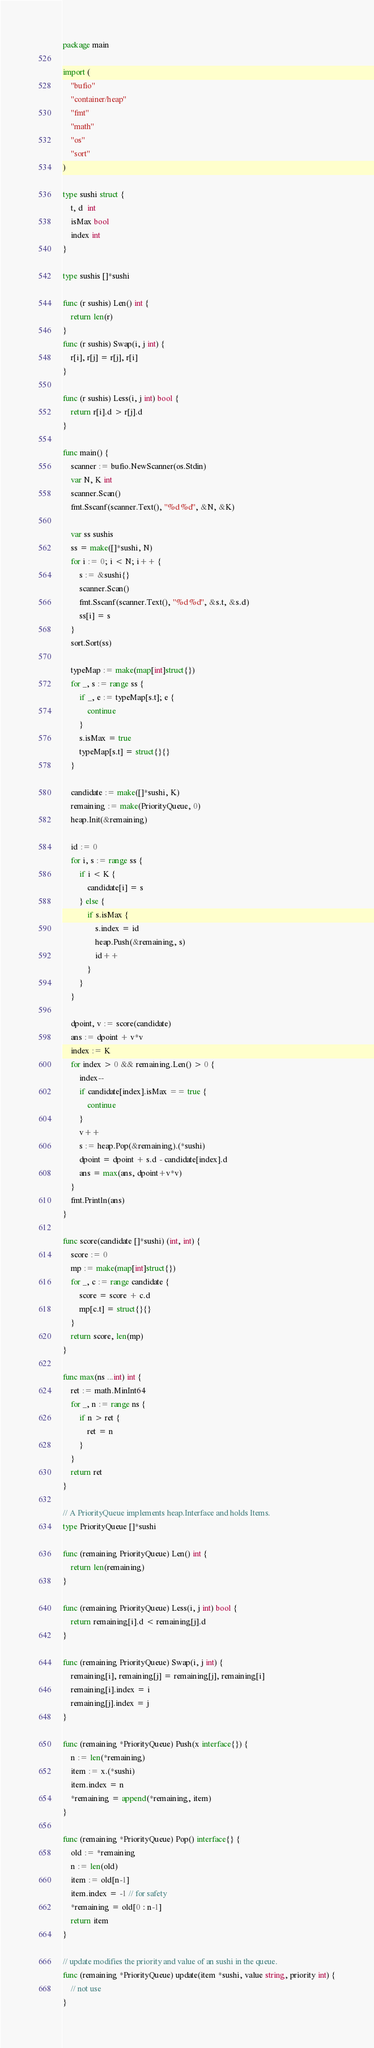Convert code to text. <code><loc_0><loc_0><loc_500><loc_500><_Go_>package main

import (
	"bufio"
	"container/heap"
	"fmt"
	"math"
	"os"
	"sort"
)

type sushi struct {
	t, d  int
	isMax bool
	index int
}

type sushis []*sushi

func (r sushis) Len() int {
	return len(r)
}
func (r sushis) Swap(i, j int) {
	r[i], r[j] = r[j], r[i]
}

func (r sushis) Less(i, j int) bool {
	return r[i].d > r[j].d
}

func main() {
	scanner := bufio.NewScanner(os.Stdin)
	var N, K int
	scanner.Scan()
	fmt.Sscanf(scanner.Text(), "%d %d", &N, &K)

	var ss sushis
	ss = make([]*sushi, N)
	for i := 0; i < N; i++ {
		s := &sushi{}
		scanner.Scan()
		fmt.Sscanf(scanner.Text(), "%d %d", &s.t, &s.d)
		ss[i] = s
	}
	sort.Sort(ss)

	typeMap := make(map[int]struct{})
	for _, s := range ss {
		if _, e := typeMap[s.t]; e {
			continue
		}
		s.isMax = true
		typeMap[s.t] = struct{}{}
	}

	candidate := make([]*sushi, K)
	remaining := make(PriorityQueue, 0)
	heap.Init(&remaining)

	id := 0
	for i, s := range ss {
		if i < K {
			candidate[i] = s
		} else {
			if s.isMax {
				s.index = id
				heap.Push(&remaining, s)
				id++
			}
		}
	}

	dpoint, v := score(candidate)
	ans := dpoint + v*v
	index := K
	for index > 0 && remaining.Len() > 0 {
		index--
		if candidate[index].isMax == true {
			continue
		}
		v++
		s := heap.Pop(&remaining).(*sushi)
		dpoint = dpoint + s.d - candidate[index].d
		ans = max(ans, dpoint+v*v)
	}
	fmt.Println(ans)
}

func score(candidate []*sushi) (int, int) {
	score := 0
	mp := make(map[int]struct{})
	for _, c := range candidate {
		score = score + c.d
		mp[c.t] = struct{}{}
	}
	return score, len(mp)
}

func max(ns ...int) int {
	ret := math.MinInt64
	for _, n := range ns {
		if n > ret {
			ret = n
		}
	}
	return ret
}

// A PriorityQueue implements heap.Interface and holds Items.
type PriorityQueue []*sushi

func (remaining PriorityQueue) Len() int {
	return len(remaining)
}

func (remaining PriorityQueue) Less(i, j int) bool {
	return remaining[i].d < remaining[j].d
}

func (remaining PriorityQueue) Swap(i, j int) {
	remaining[i], remaining[j] = remaining[j], remaining[i]
	remaining[i].index = i
	remaining[j].index = j
}

func (remaining *PriorityQueue) Push(x interface{}) {
	n := len(*remaining)
	item := x.(*sushi)
	item.index = n
	*remaining = append(*remaining, item)
}

func (remaining *PriorityQueue) Pop() interface{} {
	old := *remaining
	n := len(old)
	item := old[n-1]
	item.index = -1 // for safety
	*remaining = old[0 : n-1]
	return item
}

// update modifies the priority and value of an sushi in the queue.
func (remaining *PriorityQueue) update(item *sushi, value string, priority int) {
	// not use
}
</code> 